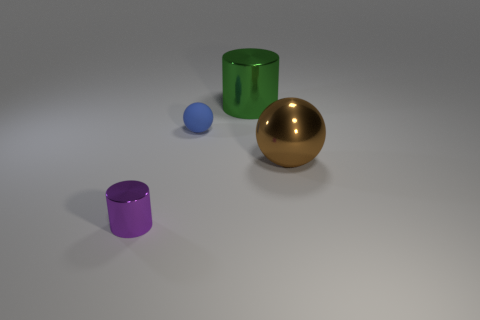Subtract all brown spheres. Subtract all green cylinders. How many spheres are left? 1 Add 2 tiny matte blocks. How many objects exist? 6 Add 3 large shiny objects. How many large shiny objects exist? 5 Subtract 0 yellow balls. How many objects are left? 4 Subtract all big cyan shiny cubes. Subtract all green shiny cylinders. How many objects are left? 3 Add 3 cylinders. How many cylinders are left? 5 